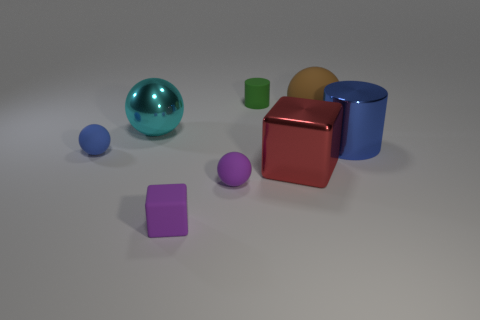Add 1 tiny green metal blocks. How many objects exist? 9 Subtract all blocks. How many objects are left? 6 Subtract all large cyan spheres. Subtract all purple balls. How many objects are left? 6 Add 4 big brown things. How many big brown things are left? 5 Add 1 big cylinders. How many big cylinders exist? 2 Subtract 0 green blocks. How many objects are left? 8 